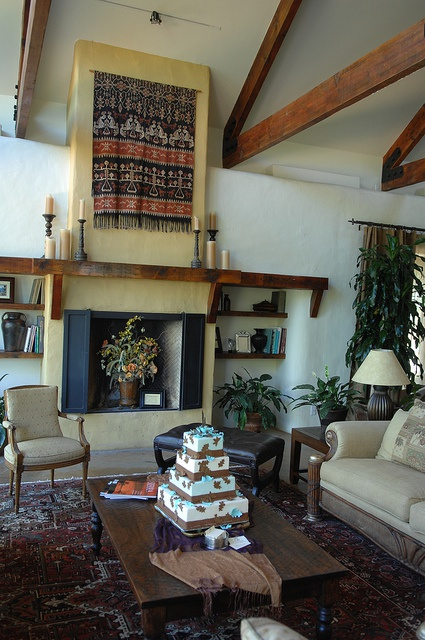Describe the objects in this image and their specific colors. I can see dining table in darkgray, black, and gray tones, couch in darkgray, gray, and black tones, potted plant in darkgray, black, gray, ivory, and darkgreen tones, cake in darkgray, lightblue, white, and gray tones, and chair in darkgray, gray, and black tones in this image. 